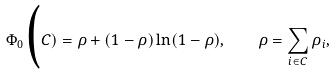Convert formula to latex. <formula><loc_0><loc_0><loc_500><loc_500>\Phi _ { 0 } \Big ( C ) = \rho + ( 1 - \rho ) \ln ( 1 - \rho ) , \quad \rho = \sum _ { i \in C } \rho _ { i } ,</formula> 